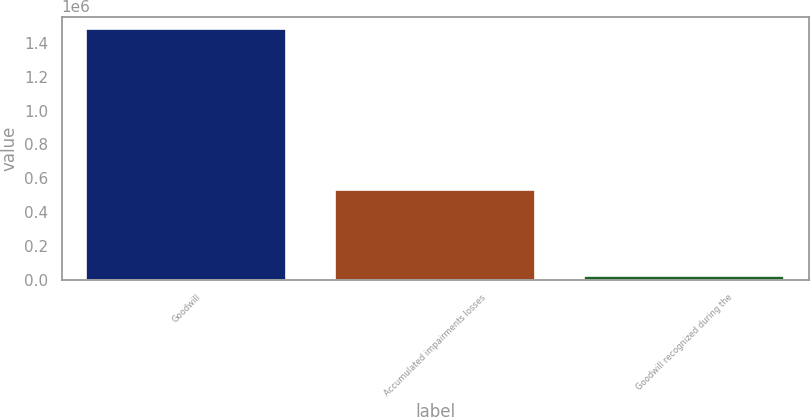Convert chart to OTSL. <chart><loc_0><loc_0><loc_500><loc_500><bar_chart><fcel>Goodwill<fcel>Accumulated impairments losses<fcel>Goodwill recognized during the<nl><fcel>1.48223e+06<fcel>531930<fcel>19821<nl></chart> 